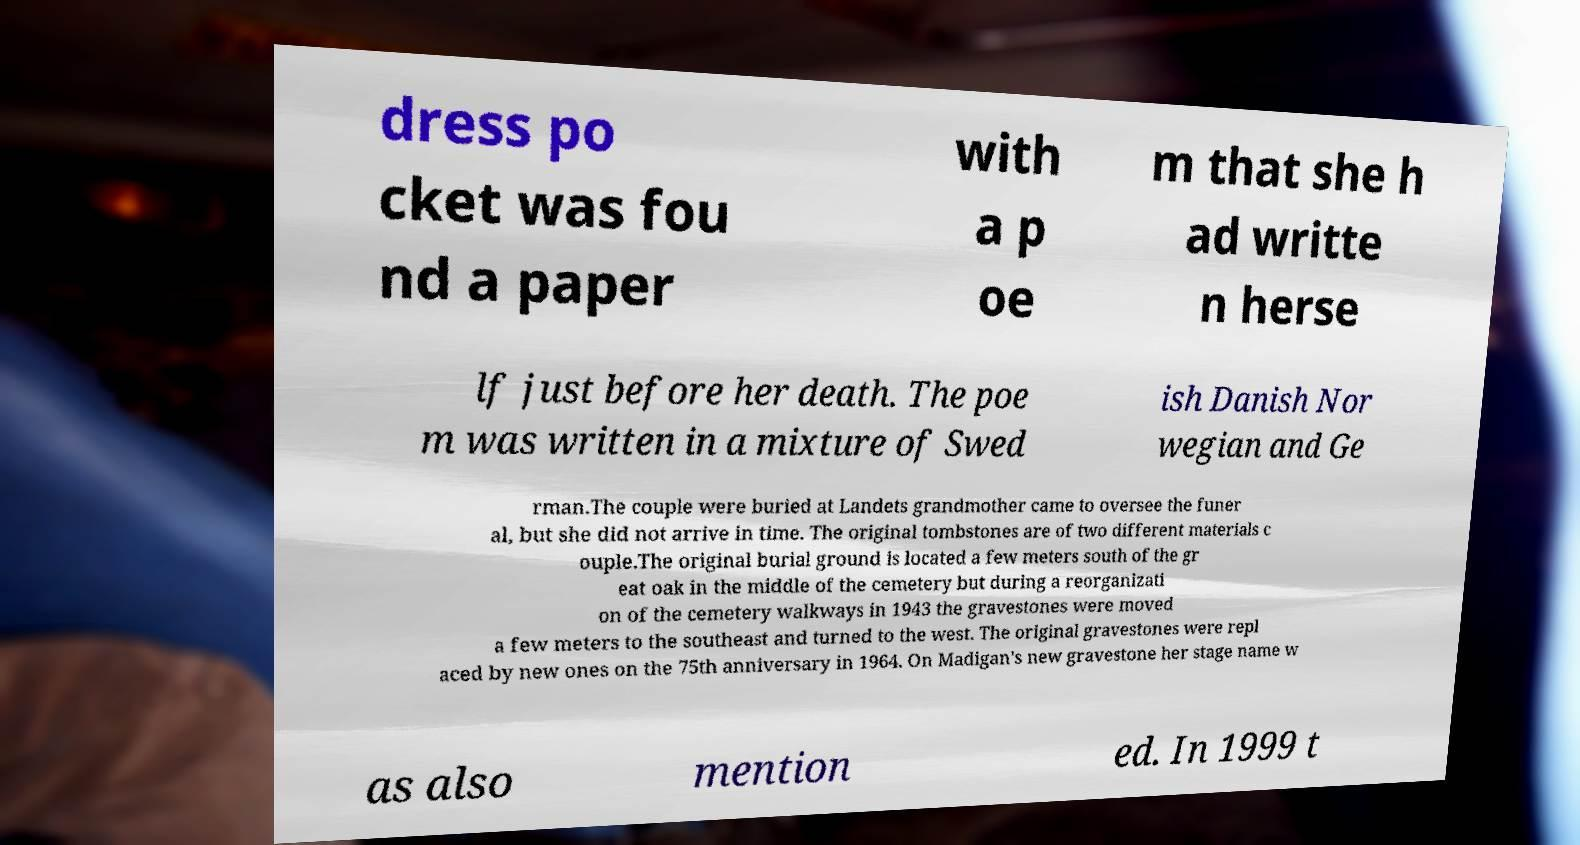For documentation purposes, I need the text within this image transcribed. Could you provide that? dress po cket was fou nd a paper with a p oe m that she h ad writte n herse lf just before her death. The poe m was written in a mixture of Swed ish Danish Nor wegian and Ge rman.The couple were buried at Landets grandmother came to oversee the funer al, but she did not arrive in time. The original tombstones are of two different materials c ouple.The original burial ground is located a few meters south of the gr eat oak in the middle of the cemetery but during a reorganizati on of the cemetery walkways in 1943 the gravestones were moved a few meters to the southeast and turned to the west. The original gravestones were repl aced by new ones on the 75th anniversary in 1964. On Madigan's new gravestone her stage name w as also mention ed. In 1999 t 